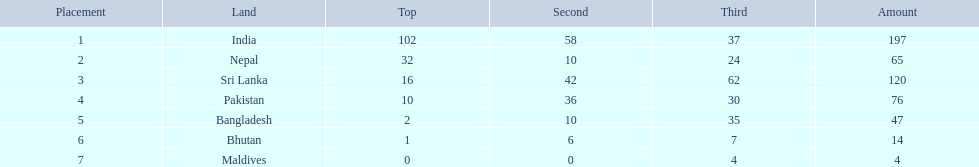Can you give me this table in json format? {'header': ['Placement', 'Land', 'Top', 'Second', 'Third', 'Amount'], 'rows': [['1', 'India', '102', '58', '37', '197'], ['2', 'Nepal', '32', '10', '24', '65'], ['3', 'Sri Lanka', '16', '42', '62', '120'], ['4', 'Pakistan', '10', '36', '30', '76'], ['5', 'Bangladesh', '2', '10', '35', '47'], ['6', 'Bhutan', '1', '6', '7', '14'], ['7', 'Maldives', '0', '0', '4', '4']]} What are the totals of medals one in each country? 197, 65, 120, 76, 47, 14, 4. Which of these totals are less than 10? 4. Who won this number of medals? Maldives. 